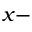Convert formula to latex. <formula><loc_0><loc_0><loc_500><loc_500>x -</formula> 